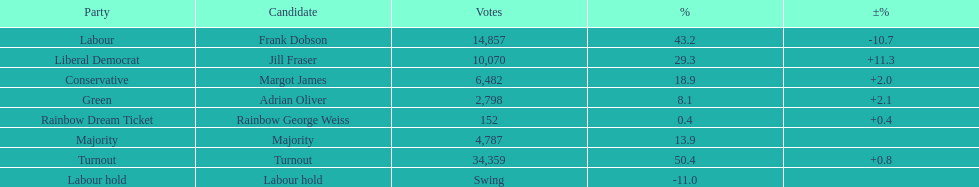How many votes did both the conservative party and the rainbow dream ticket party receive? 6634. 